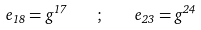<formula> <loc_0><loc_0><loc_500><loc_500>e _ { 1 8 } = g ^ { 1 7 } \quad ; \quad e _ { 2 3 } = g ^ { 2 4 }</formula> 